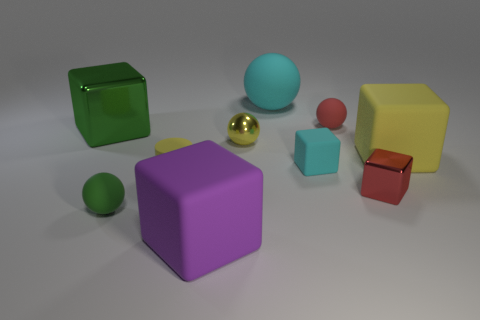There is a large block in front of the small rubber ball that is in front of the tiny red ball; what number of green shiny blocks are behind it? I am unable to provide a current count of green shiny blocks behind the large block because the perspective of the provided image does not reveal the space behind the large block. The image shows a variety of colorful blocks and balls of different sizes and textures, but any objects outside of the visible area cannot be counted or described. 